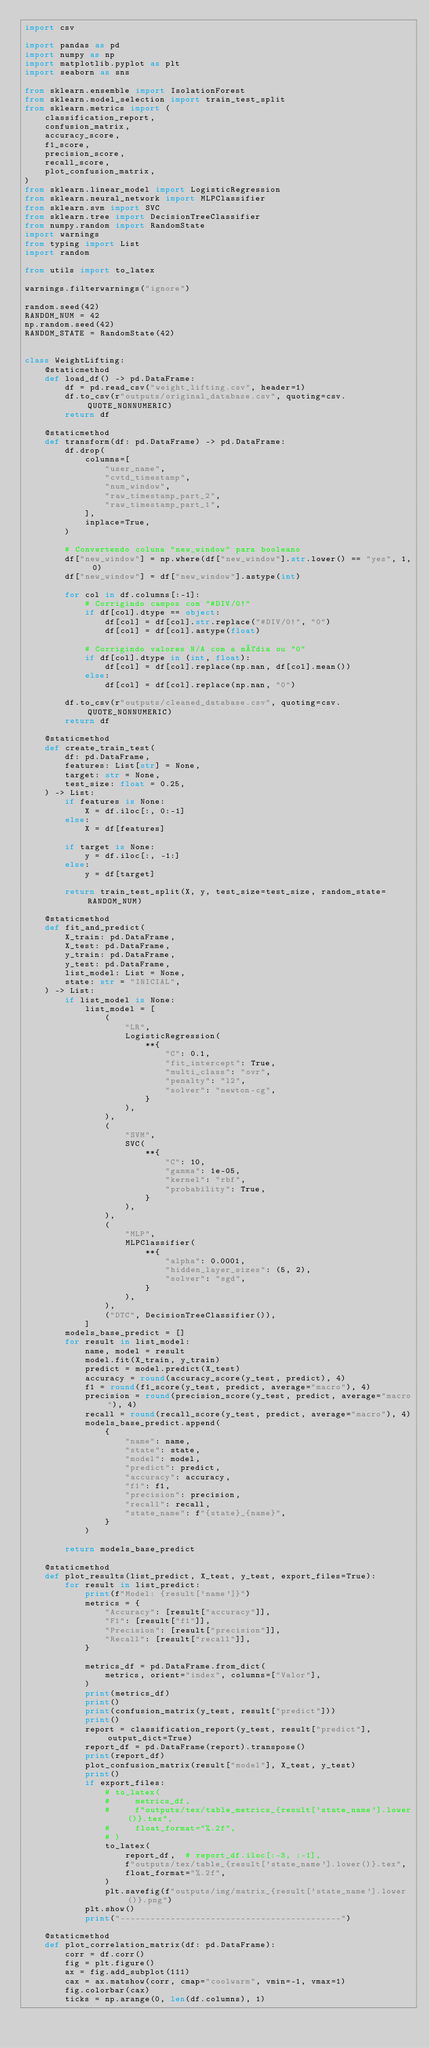Convert code to text. <code><loc_0><loc_0><loc_500><loc_500><_Python_>import csv

import pandas as pd
import numpy as np
import matplotlib.pyplot as plt
import seaborn as sns

from sklearn.ensemble import IsolationForest
from sklearn.model_selection import train_test_split
from sklearn.metrics import (
    classification_report,
    confusion_matrix,
    accuracy_score,
    f1_score,
    precision_score,
    recall_score,
    plot_confusion_matrix,
)
from sklearn.linear_model import LogisticRegression
from sklearn.neural_network import MLPClassifier
from sklearn.svm import SVC
from sklearn.tree import DecisionTreeClassifier
from numpy.random import RandomState
import warnings
from typing import List
import random

from utils import to_latex

warnings.filterwarnings("ignore")

random.seed(42)
RANDOM_NUM = 42
np.random.seed(42)
RANDOM_STATE = RandomState(42)


class WeightLifting:
    @staticmethod
    def load_df() -> pd.DataFrame:
        df = pd.read_csv("weight_lifting.csv", header=1)
        df.to_csv(r"outputs/original_database.csv", quoting=csv.QUOTE_NONNUMERIC)
        return df

    @staticmethod
    def transform(df: pd.DataFrame) -> pd.DataFrame:
        df.drop(
            columns=[
                "user_name",
                "cvtd_timestamp",
                "num_window",
                "raw_timestamp_part_2",
                "raw_timestamp_part_1",
            ],
            inplace=True,
        )

        # Convertendo coluna "new_window" para booleano
        df["new_window"] = np.where(df["new_window"].str.lower() == "yes", 1, 0)
        df["new_window"] = df["new_window"].astype(int)

        for col in df.columns[:-1]:
            # Corrigindo campos com "#DIV/0!"
            if df[col].dtype == object:
                df[col] = df[col].str.replace("#DIV/0!", "0")
                df[col] = df[col].astype(float)

            # Corrigindo valores N/A com a média ou "0"
            if df[col].dtype in (int, float):
                df[col] = df[col].replace(np.nan, df[col].mean())
            else:
                df[col] = df[col].replace(np.nan, "0")

        df.to_csv(r"outputs/cleaned_database.csv", quoting=csv.QUOTE_NONNUMERIC)
        return df

    @staticmethod
    def create_train_test(
        df: pd.DataFrame,
        features: List[str] = None,
        target: str = None,
        test_size: float = 0.25,
    ) -> List:
        if features is None:
            X = df.iloc[:, 0:-1]
        else:
            X = df[features]

        if target is None:
            y = df.iloc[:, -1:]
        else:
            y = df[target]

        return train_test_split(X, y, test_size=test_size, random_state=RANDOM_NUM)

    @staticmethod
    def fit_and_predict(
        X_train: pd.DataFrame,
        X_test: pd.DataFrame,
        y_train: pd.DataFrame,
        y_test: pd.DataFrame,
        list_model: List = None,
        state: str = "INICIAL",
    ) -> List:
        if list_model is None:
            list_model = [
                (
                    "LR",
                    LogisticRegression(
                        **{
                            "C": 0.1,
                            "fit_intercept": True,
                            "multi_class": "ovr",
                            "penalty": "l2",
                            "solver": "newton-cg",
                        }
                    ),
                ),
                (
                    "SVM",
                    SVC(
                        **{
                            "C": 10,
                            "gamma": 1e-05,
                            "kernel": "rbf",
                            "probability": True,
                        }
                    ),
                ),
                (
                    "MLP",
                    MLPClassifier(
                        **{
                            "alpha": 0.0001,
                            "hidden_layer_sizes": (5, 2),
                            "solver": "sgd",
                        }
                    ),
                ),
                ("DTC", DecisionTreeClassifier()),
            ]
        models_base_predict = []
        for result in list_model:
            name, model = result
            model.fit(X_train, y_train)
            predict = model.predict(X_test)
            accuracy = round(accuracy_score(y_test, predict), 4)
            f1 = round(f1_score(y_test, predict, average="macro"), 4)
            precision = round(precision_score(y_test, predict, average="macro"), 4)
            recall = round(recall_score(y_test, predict, average="macro"), 4)
            models_base_predict.append(
                {
                    "name": name,
                    "state": state,
                    "model": model,
                    "predict": predict,
                    "accuracy": accuracy,
                    "f1": f1,
                    "precision": precision,
                    "recall": recall,
                    "state_name": f"{state}_{name}",
                }
            )

        return models_base_predict

    @staticmethod
    def plot_results(list_predict, X_test, y_test, export_files=True):
        for result in list_predict:
            print(f"Model: {result['name']}")
            metrics = {
                "Accuracy": [result["accuracy"]],
                "F1": [result["f1"]],
                "Precision": [result["precision"]],
                "Recall": [result["recall"]],
            }

            metrics_df = pd.DataFrame.from_dict(
                metrics, orient="index", columns=["Valor"],
            )
            print(metrics_df)
            print()
            print(confusion_matrix(y_test, result["predict"]))
            print()
            report = classification_report(y_test, result["predict"], output_dict=True)
            report_df = pd.DataFrame(report).transpose()
            print(report_df)
            plot_confusion_matrix(result["model"], X_test, y_test)
            print()
            if export_files:
                # to_latex(
                #     metrics_df,
                #     f"outputs/tex/table_metrics_{result['state_name'].lower()}.tex",
                #     float_format="%.2f",
                # )
                to_latex(
                    report_df,  # report_df.iloc[:-3, :-1],
                    f"outputs/tex/table_{result['state_name'].lower()}.tex",
                    float_format="%.2f",
                )
                plt.savefig(f"outputs/img/matrix_{result['state_name'].lower()}.png")
            plt.show()
            print("--------------------------------------------")

    @staticmethod
    def plot_correlation_matrix(df: pd.DataFrame):
        corr = df.corr()
        fig = plt.figure()
        ax = fig.add_subplot(111)
        cax = ax.matshow(corr, cmap="coolwarm", vmin=-1, vmax=1)
        fig.colorbar(cax)
        ticks = np.arange(0, len(df.columns), 1)</code> 